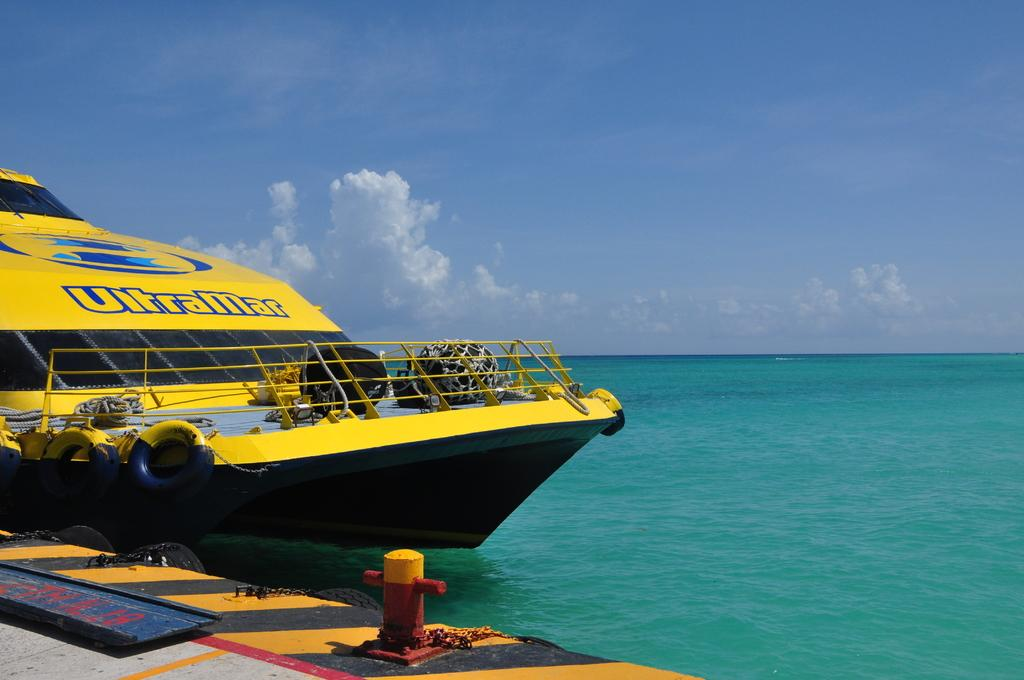Provide a one-sentence caption for the provided image. An UltraMar boat is bright yellow and is at the dock. 